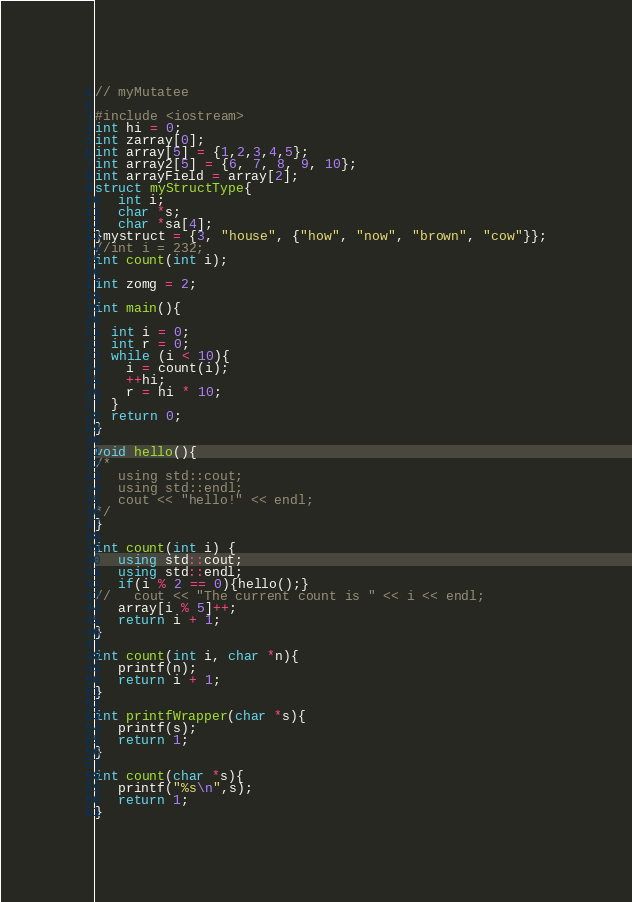<code> <loc_0><loc_0><loc_500><loc_500><_C++_>// myMutatee

#include <iostream>
int hi = 0;
int zarray[0];
int array[5] = {1,2,3,4,5};
int array2[5] = {6, 7, 8, 9, 10};
int arrayField = array[2];
struct myStructType{
   int i;
   char *s;
   char *sa[4];
}mystruct = {3, "house", {"how", "now", "brown", "cow"}};
//int i = 232;
int count(int i);

int zomg = 2;

int main(){
   
  int i = 0;
  int r = 0;
  while (i < 10){
    i = count(i);
    ++hi;
    r = hi * 10;
  }
  return 0;
}

void hello(){
/*
   using std::cout;
   using std::endl;
   cout << "hello!" << endl;
*/
}

int count(int i) {
   using std::cout;
   using std::endl;
   if(i % 2 == 0){hello();}
//   cout << "The current count is " << i << endl;
   array[i % 5]++; 
   return i + 1;
}

int count(int i, char *n){
   printf(n);
   return i + 1;
}

int printfWrapper(char *s){
   printf(s);
   return 1;
}

int count(char *s){
   printf("%s\n",s);
   return 1;
}

</code> 